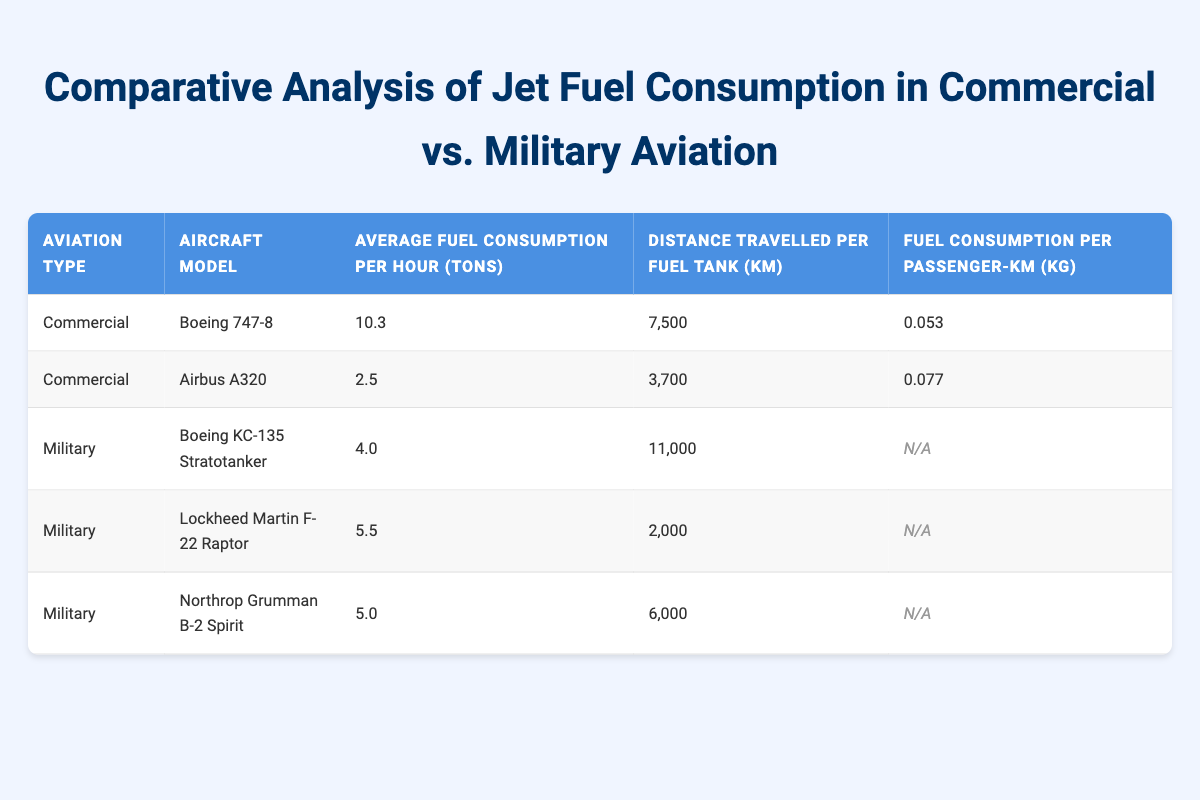What is the average fuel consumption per hour for the Boeing 747-8? The table indicates that the average fuel consumption per hour for the Boeing 747-8 is listed directly as 10.3 tons.
Answer: 10.3 tons Which aircraft has the highest distance travelled per fuel tank? By comparing the values in the "Distance Travelled per Fuel Tank" column, the Boeing KC-135 Stratotanker shows the highest distance at 11,000 km.
Answer: Boeing KC-135 Stratotanker What are the average fuel consumption values for Military aircraft? The average fuel consumption for Military aircraft is 4.0 tons for the Boeing KC-135 Stratotanker, 5.5 tons for the F-22 Raptor, and 5.0 tons for the B-2 Spirit. To find the average, sum them up (4.0 + 5.5 + 5.0) = 14.5 tons and divide by the number of aircraft (3), resulting in an average of approximately 4.83 tons.
Answer: 4.83 tons Is the fuel consumption per passenger-km available for the military aircraft? The data for fuel consumption per passenger-km for all military aircraft is listed as "N/A", which indicates that this information is not available for any of the military models.
Answer: No Which aviation type has a higher average fuel consumption per hour based on the provided aircraft models? Calculate the average fuel consumption for Commercial aircraft: (10.3 + 2.5) / 2 = 6.4 tons. For Military aircraft: (4.0 + 5.5 + 5.0) / 3 = 4.83 tons. Comparing the averages, 6.4 tons for Commercial is greater than 4.83 tons for Military.
Answer: Commercial aviation What is the fuel consumption per passenger-km for the Airbus A320? The table states that the fuel consumption per passenger-km for the Airbus A320 is 0.077 kg, which is a direct retrieval from the table under its corresponding data entry.
Answer: 0.077 kg Which aircraft has the highest average fuel consumption per hour among the Commercial types? The Boeing 747-8 has the highest average fuel consumption per hour among the Commercial aircraft, with a value of 10.3 tons compared to the Airbus A320's 2.5 tons.
Answer: Boeing 747-8 How does the distance travelled per fuel tank for military aircraft compare with commercial aircraft? For Commercial aircraft, the distance per fuel tank is 7,500 km (Boeing 747-8) and 3,700 km (Airbus A320). For Military, the values are 11,000 km (Boeing KC-135), 2,000 km (F-22), and 6,000 km (B-2). Comparing these, the Military aircraft have a higher maximum distance (11,000 km), while Commercial aircraft have lower maximum distance values.
Answer: Military aircraft have higher maximum distances 